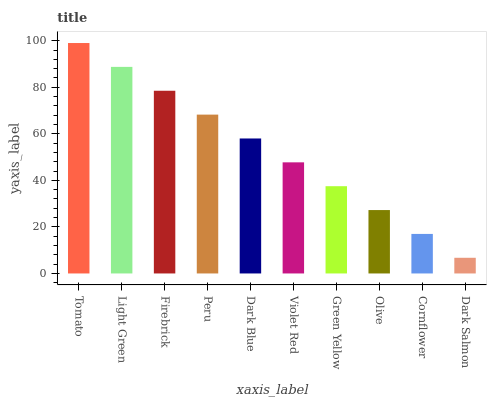Is Dark Salmon the minimum?
Answer yes or no. Yes. Is Tomato the maximum?
Answer yes or no. Yes. Is Light Green the minimum?
Answer yes or no. No. Is Light Green the maximum?
Answer yes or no. No. Is Tomato greater than Light Green?
Answer yes or no. Yes. Is Light Green less than Tomato?
Answer yes or no. Yes. Is Light Green greater than Tomato?
Answer yes or no. No. Is Tomato less than Light Green?
Answer yes or no. No. Is Dark Blue the high median?
Answer yes or no. Yes. Is Violet Red the low median?
Answer yes or no. Yes. Is Cornflower the high median?
Answer yes or no. No. Is Dark Salmon the low median?
Answer yes or no. No. 